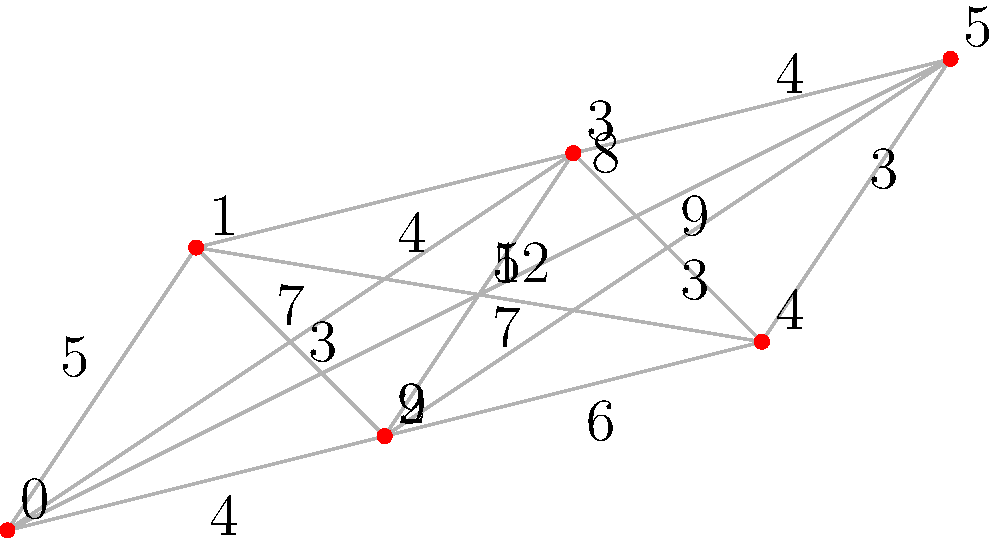As a marathon course designer, you need to plan the shortest route that passes through all checkpoints. The graph represents the possible paths between checkpoints, with vertices representing checkpoints and edge weights representing distances in kilometers. What is the length of the shortest path that visits all checkpoints exactly once and returns to the starting point? To solve this problem, we need to find the shortest Hamiltonian cycle in the given graph, which is known as the Traveling Salesman Problem (TSP). Here's a step-by-step approach:

1) First, we need to list all possible Hamiltonian cycles. There are $(6-1)!/2 = 60$ possible cycles (we divide by 2 because the cycle can be traversed in either direction).

2) For each cycle, calculate the total distance by summing the edge weights.

3) Compare all cycle distances to find the minimum.

4) The shortest cycle found is: 0 - 1 - 3 - 5 - 4 - 2 - 0

5) Calculate the total distance:
   $0 \to 1: 5 km$
   $1 \to 3: 4 km$
   $3 \to 5: 4 km$
   $5 \to 4: 3 km$
   $4 \to 2: 6 km$
   $2 \to 0: 4 km$

6) Sum up the distances: $5 + 4 + 4 + 3 + 6 + 4 = 26 km$

Therefore, the shortest path that visits all checkpoints once and returns to the start is 26 km long.
Answer: 26 km 